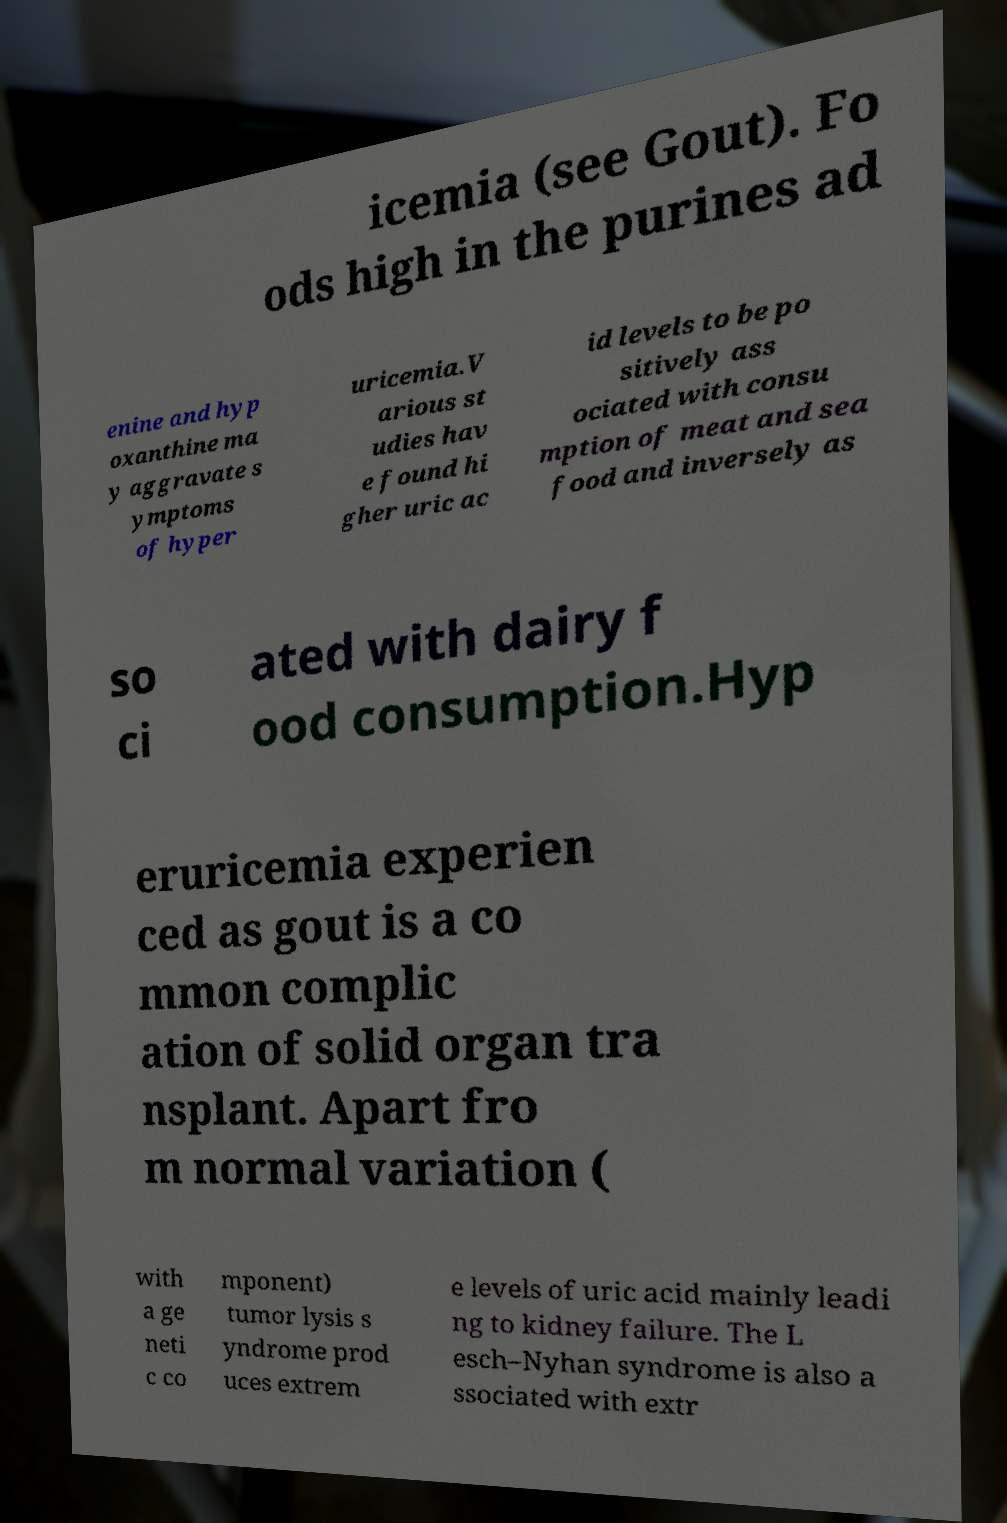Could you extract and type out the text from this image? icemia (see Gout). Fo ods high in the purines ad enine and hyp oxanthine ma y aggravate s ymptoms of hyper uricemia.V arious st udies hav e found hi gher uric ac id levels to be po sitively ass ociated with consu mption of meat and sea food and inversely as so ci ated with dairy f ood consumption.Hyp eruricemia experien ced as gout is a co mmon complic ation of solid organ tra nsplant. Apart fro m normal variation ( with a ge neti c co mponent) tumor lysis s yndrome prod uces extrem e levels of uric acid mainly leadi ng to kidney failure. The L esch–Nyhan syndrome is also a ssociated with extr 